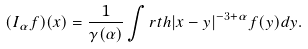<formula> <loc_0><loc_0><loc_500><loc_500>( I _ { \alpha } f ) ( x ) = \frac { 1 } { \gamma ( \alpha ) } \int _ { \ } r t h | x - y | ^ { - 3 + \alpha } f ( y ) d y .</formula> 